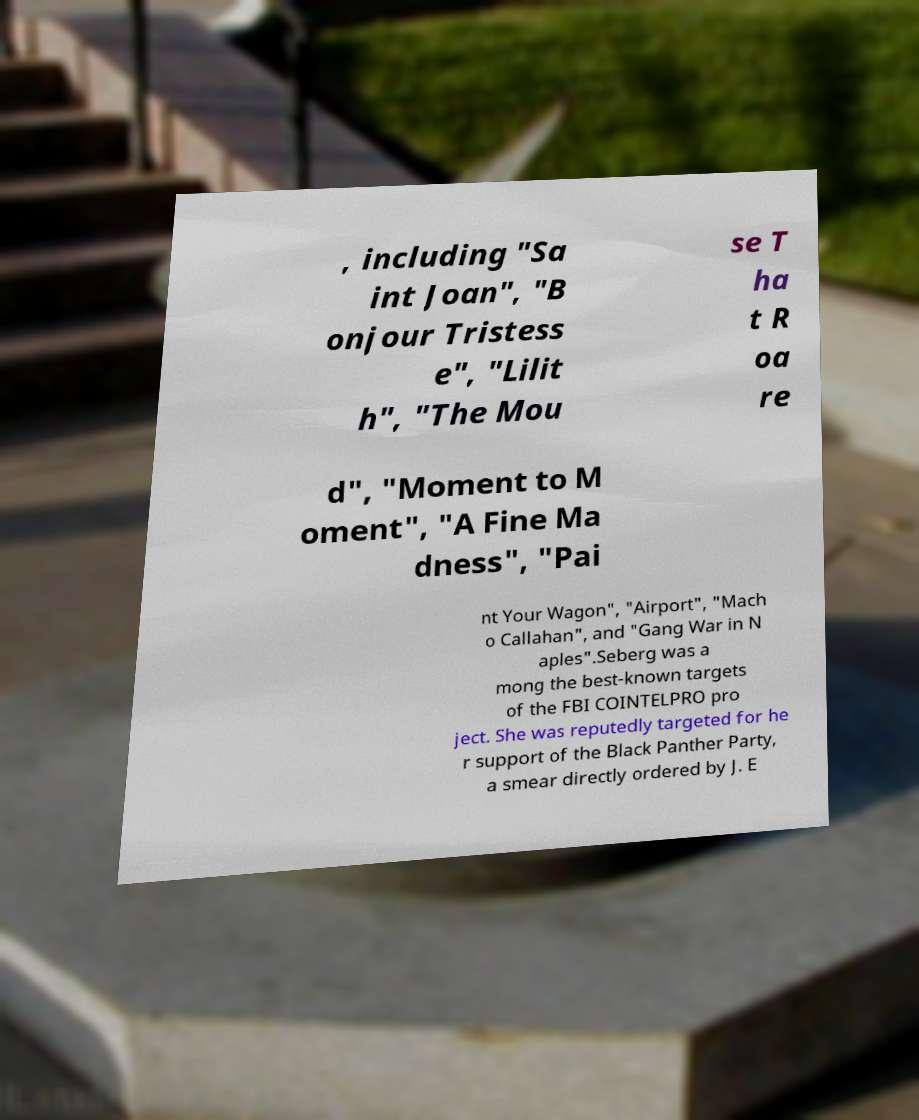I need the written content from this picture converted into text. Can you do that? , including "Sa int Joan", "B onjour Tristess e", "Lilit h", "The Mou se T ha t R oa re d", "Moment to M oment", "A Fine Ma dness", "Pai nt Your Wagon", "Airport", "Mach o Callahan", and "Gang War in N aples".Seberg was a mong the best-known targets of the FBI COINTELPRO pro ject. She was reputedly targeted for he r support of the Black Panther Party, a smear directly ordered by J. E 